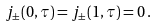Convert formula to latex. <formula><loc_0><loc_0><loc_500><loc_500>j _ { \pm } ( 0 , \tau ) = j _ { \pm } ( 1 , \tau ) = 0 \, .</formula> 